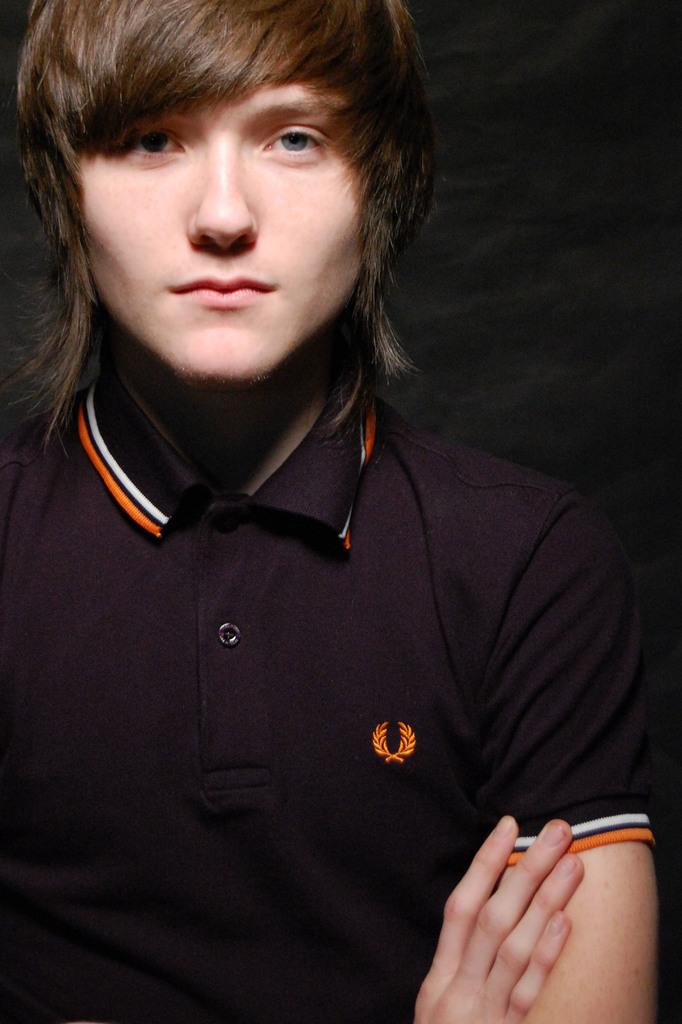What is the main subject of the image? The main subject of the image is a person standing. What is the person wearing in the image? The person is wearing a black color t-shirt. What type of distance is being measured in the image? There is no indication of any distance being measured in the image. What type of society is depicted in the image? The image only shows a person standing, and there is no indication of any specific society. 